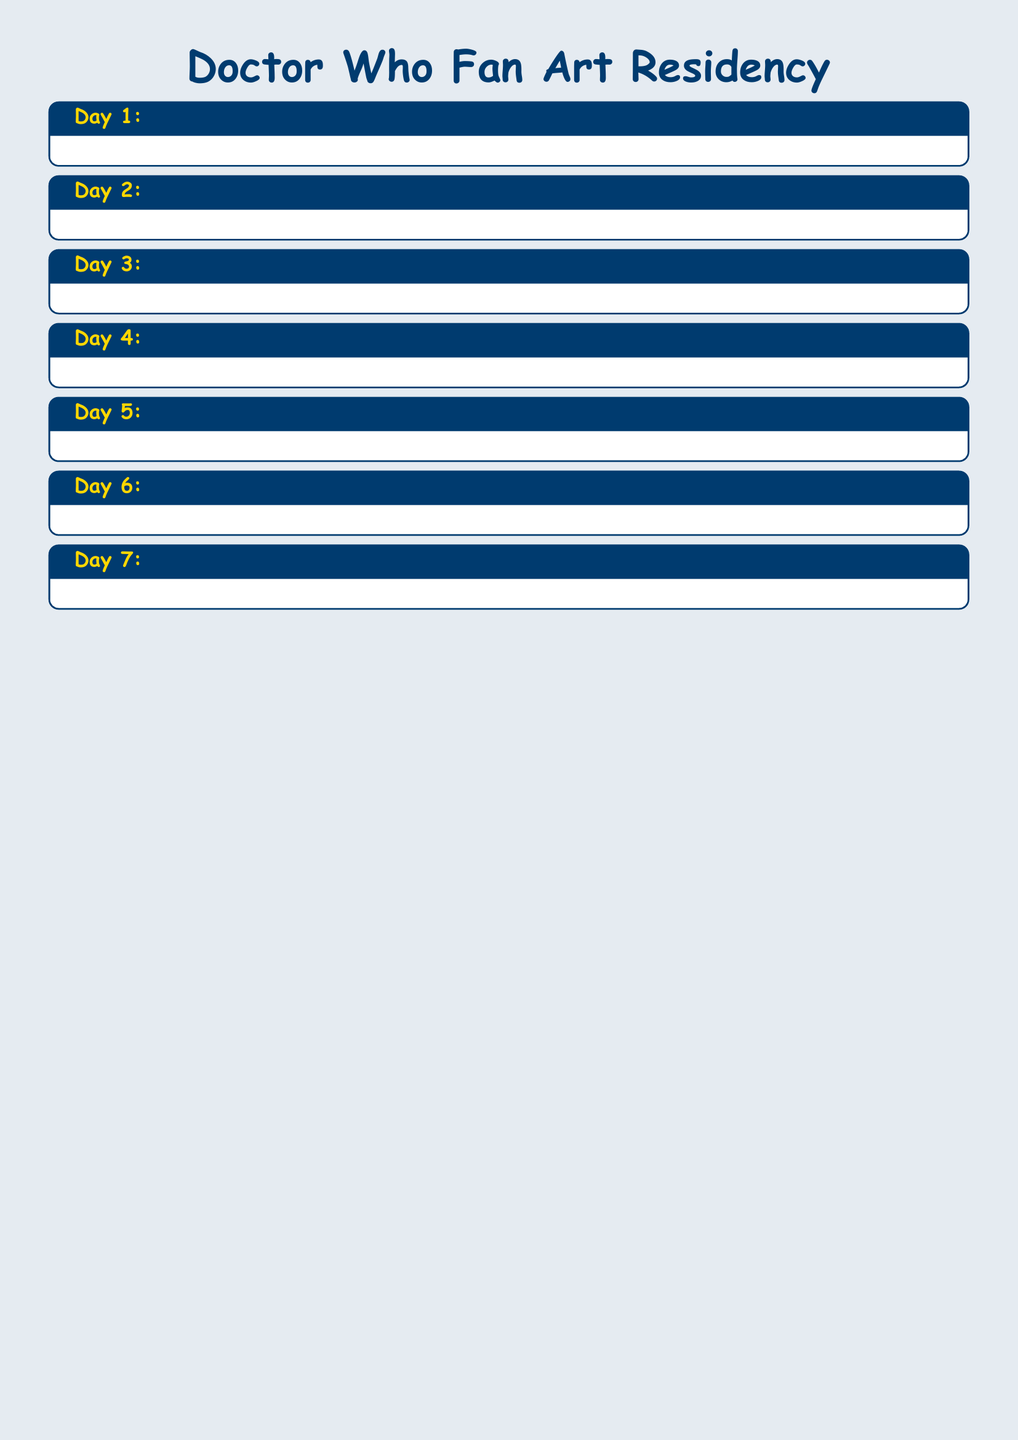What is the title of Day 1? The title for Day 1 is written at the beginning of the day's activities.
Answer: Welcome and Orientation Who is the instructor for Day 2's character design workshop? The instructor's name is provided in the details of the workshop for Day 2.
Answer: Mark Reynolds What is the total number of activities scheduled for Day 5? The number of activities for Day 5 can be counted in the day's section.
Answer: 3 What time does the art exhibition setup start on Day 7? The start time for the art exhibition setup is listed in Day 7's schedule.
Answer: 10:00 AM Which day features the excursion to film locations? The day for the excursion is specified in the title for the day's activities.
Answer: Day 4 What activity occurs on Day 6 from 5:00 PM to 7:00 PM? The specific activity for that time slot is mentioned in Day 6's schedule.
Answer: Panel Discussion: Building a Fan Art Community Where is the cosplay photoshoot session held? The location for the cosplay photoshoot is indicated in Day 5's activities.
Answer: Residency Gardens How many hours is the final art showcase scheduled to last on Day 7? The duration of the final art showcase can be calculated from the start and end times provided.
Answer: 3 hours 